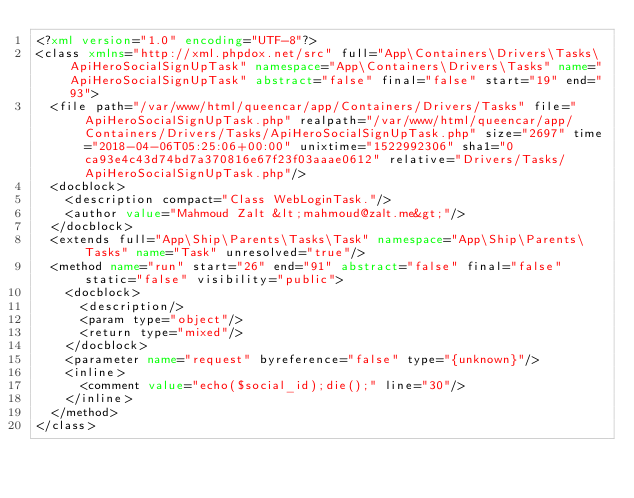<code> <loc_0><loc_0><loc_500><loc_500><_XML_><?xml version="1.0" encoding="UTF-8"?>
<class xmlns="http://xml.phpdox.net/src" full="App\Containers\Drivers\Tasks\ApiHeroSocialSignUpTask" namespace="App\Containers\Drivers\Tasks" name="ApiHeroSocialSignUpTask" abstract="false" final="false" start="19" end="93">
  <file path="/var/www/html/queencar/app/Containers/Drivers/Tasks" file="ApiHeroSocialSignUpTask.php" realpath="/var/www/html/queencar/app/Containers/Drivers/Tasks/ApiHeroSocialSignUpTask.php" size="2697" time="2018-04-06T05:25:06+00:00" unixtime="1522992306" sha1="0ca93e4c43d74bd7a370816e67f23f03aaae0612" relative="Drivers/Tasks/ApiHeroSocialSignUpTask.php"/>
  <docblock>
    <description compact="Class WebLoginTask."/>
    <author value="Mahmoud Zalt &lt;mahmoud@zalt.me&gt;"/>
  </docblock>
  <extends full="App\Ship\Parents\Tasks\Task" namespace="App\Ship\Parents\Tasks" name="Task" unresolved="true"/>
  <method name="run" start="26" end="91" abstract="false" final="false" static="false" visibility="public">
    <docblock>
      <description/>
      <param type="object"/>
      <return type="mixed"/>
    </docblock>
    <parameter name="request" byreference="false" type="{unknown}"/>
    <inline>
      <comment value="echo($social_id);die();" line="30"/>
    </inline>
  </method>
</class>
</code> 